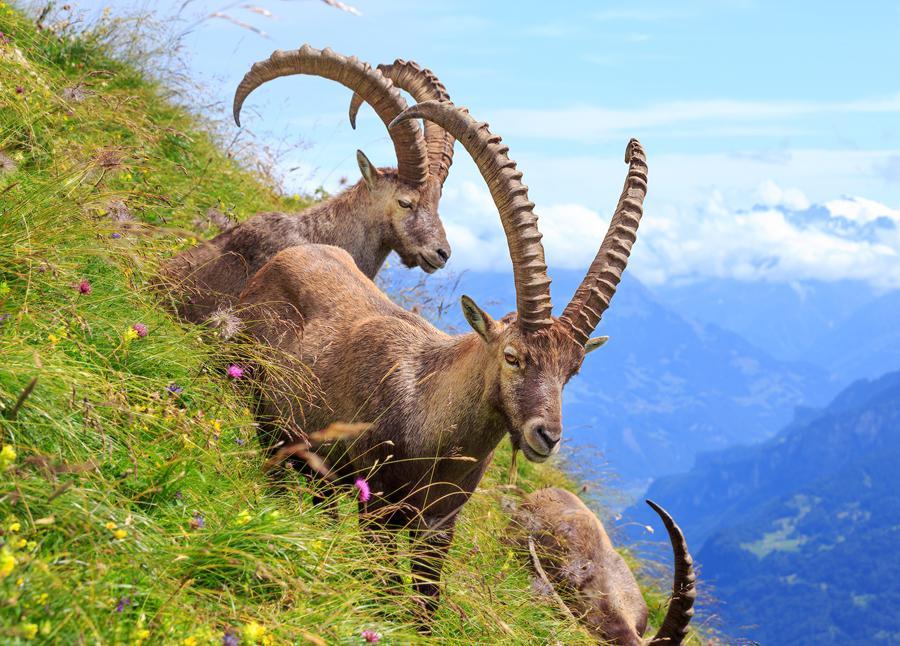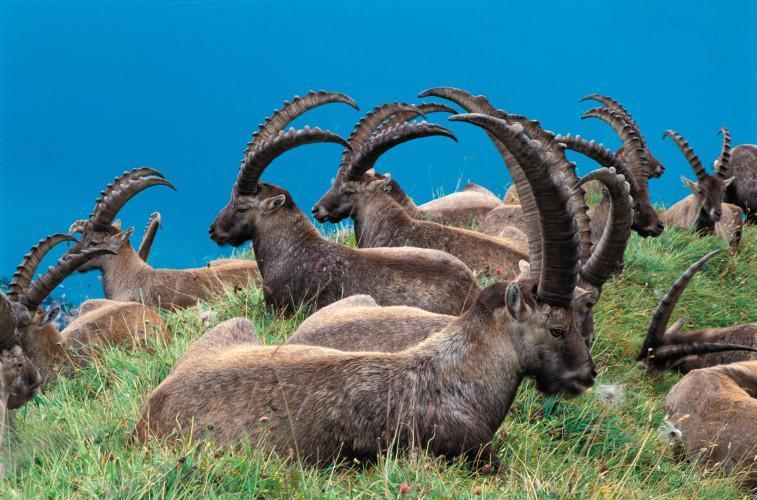The first image is the image on the left, the second image is the image on the right. For the images shown, is this caption "At least one man is posed behind a downed long-horned animal in one image." true? Answer yes or no. No. The first image is the image on the left, the second image is the image on the right. Examine the images to the left and right. Is the description "At least one person is posing with a horned animal in one of the pictures." accurate? Answer yes or no. No. 